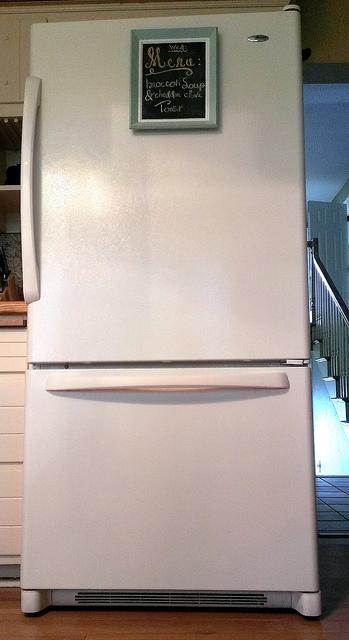What color is fridge?
Concise answer only. White. What is on the refrigerator?
Answer briefly. Chalkboard. What appliance is this?
Write a very short answer. Refrigerator. 